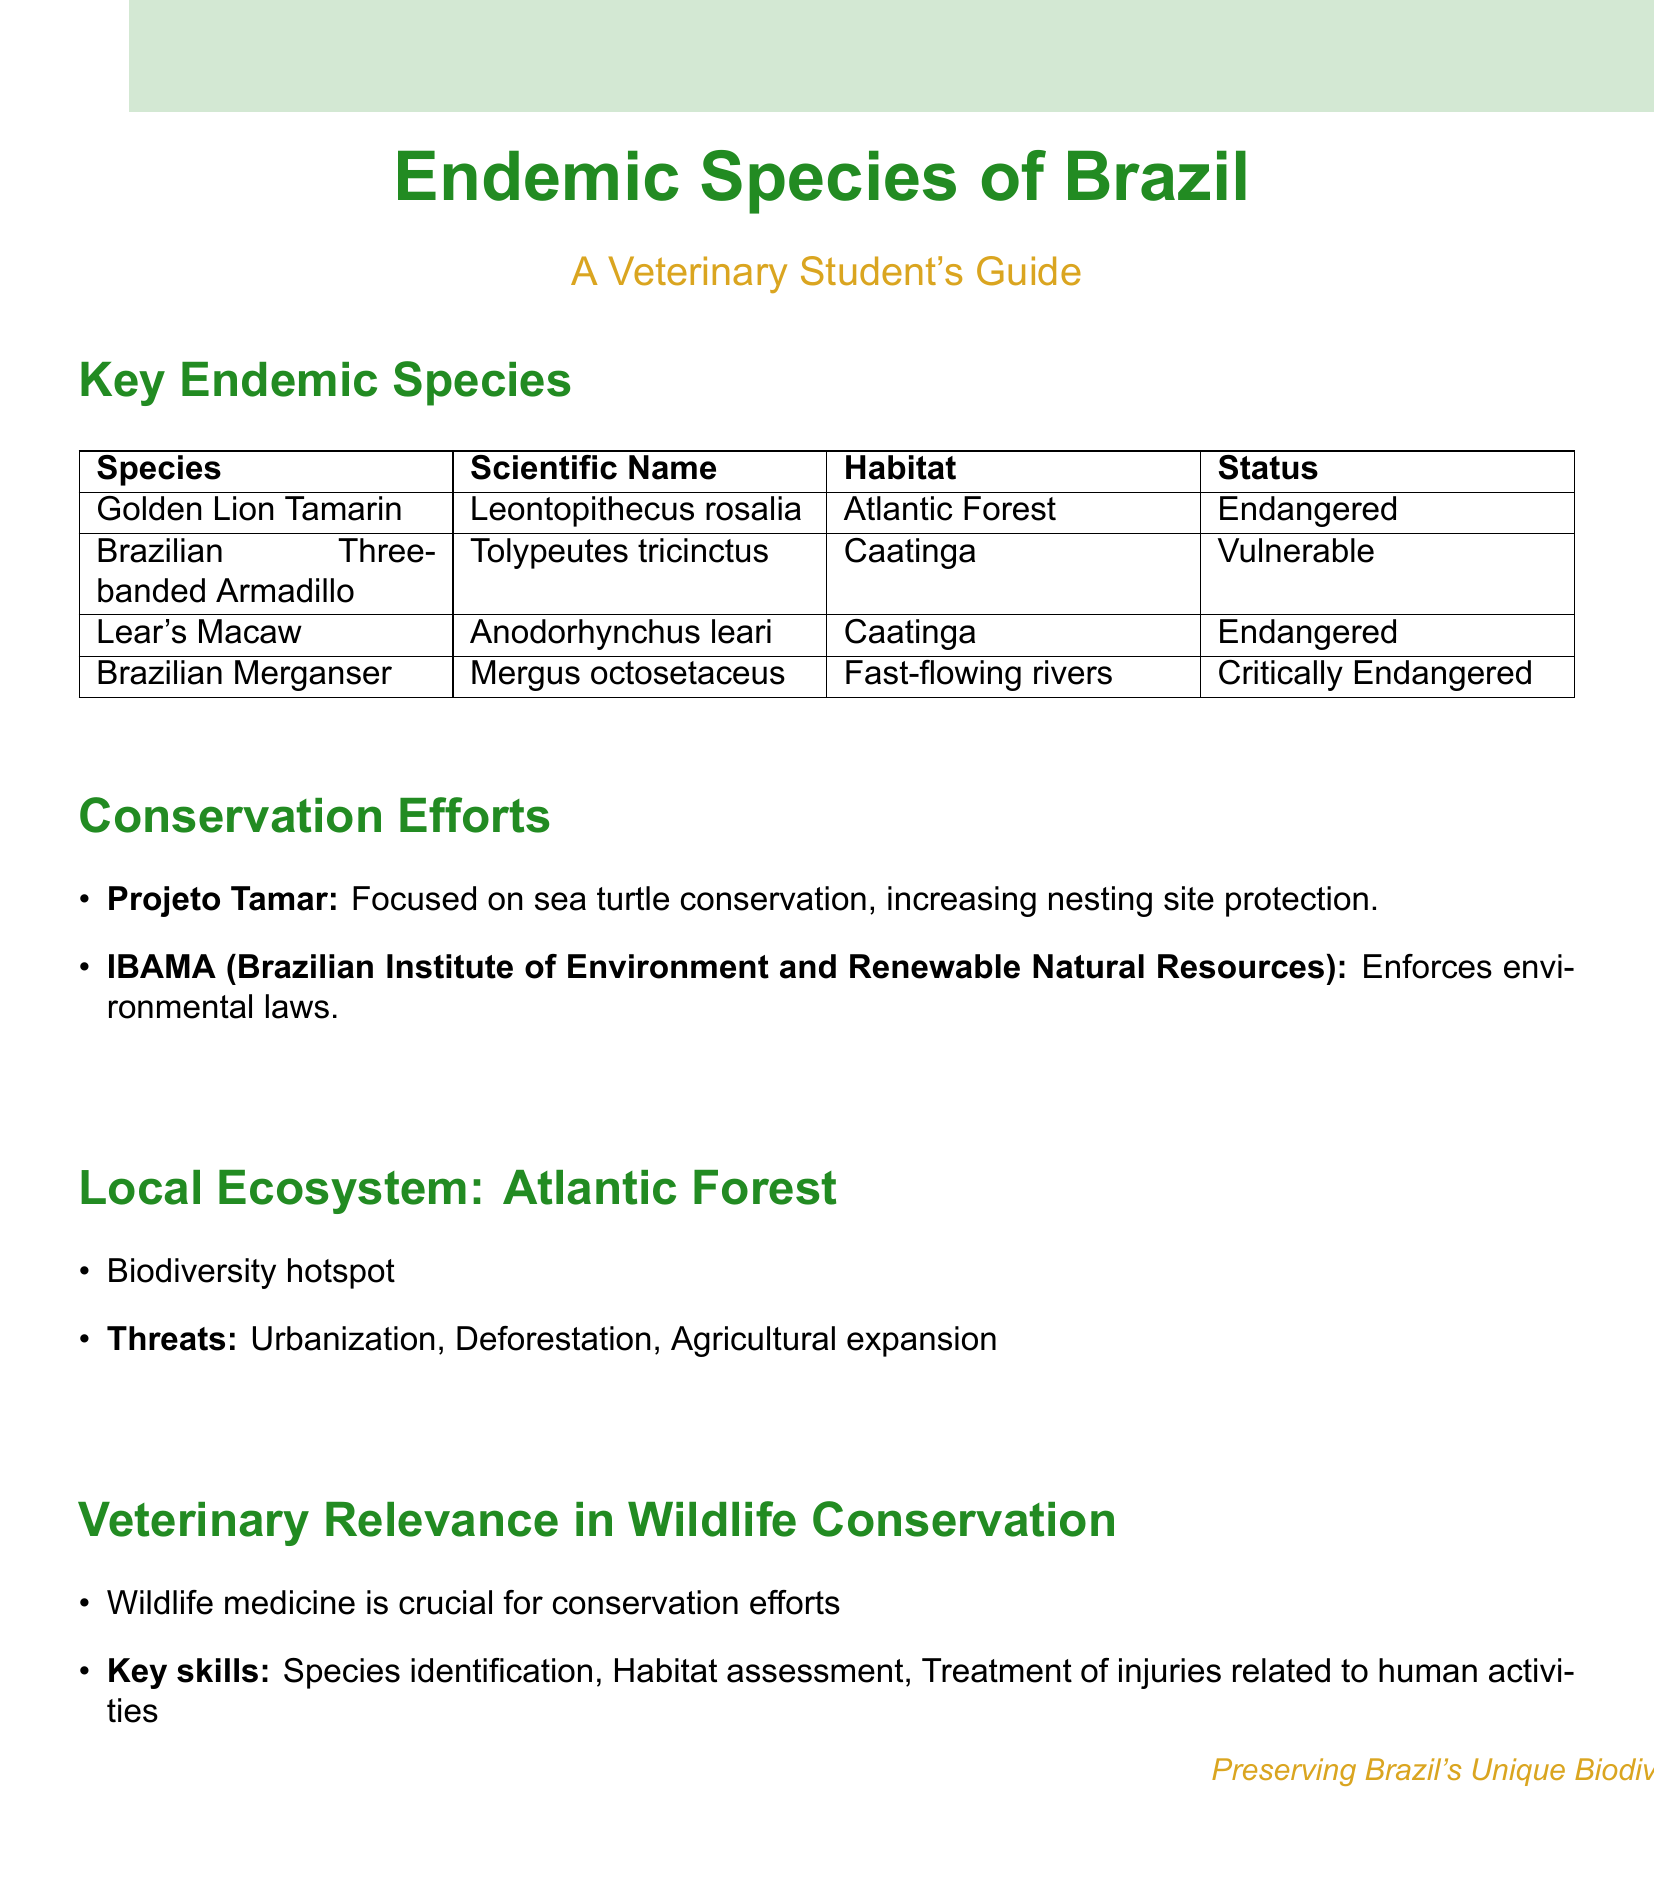What is the habitat of the Golden Lion Tamarin? The habitat of the Golden Lion Tamarin is stated in the document as the Atlantic Forest.
Answer: Atlantic Forest What is the conservation status of the Brazilian Merganser? The conservation status of the Brazilian Merganser is classified in the document as Critically Endangered.
Answer: Critically Endangered What initiative focuses on sea turtle conservation? The document mentions Projeto Tamar as the initiative focused on sea turtle conservation.
Answer: Projeto Tamar Which biome is characterized as a biodiversity hotspot? The document highlights the Atlantic Forest as the local ecosystem that is identified as a biodiversity hotspot.
Answer: Atlantic Forest What are the main threats to the local ecosystem? The main threats listed in the document for the local ecosystem include urbanization, deforestation, and agricultural expansion.
Answer: Urbanization, Deforestation, Agricultural expansion What are the key skills relevant to wildlife medicine mentioned in the document? The document outlines key skills for wildlife medicine, specifically species identification, habitat assessment, and treatment of injuries related to human activities.
Answer: Species identification, Habitat assessment, Treatment of injuries related to human activities What endangered species is found in the Caatinga habitat? The document lists Lear's Macaw and Brazilian Three-banded Armadillo as the endangered species associated with the Caatinga habitat.
Answer: Lear's Macaw How does IBAMA contribute to conservation efforts? The document describes IBAMA's role as enforcing environmental laws, which contributes to conservation efforts.
Answer: Enforcement of environmental laws 